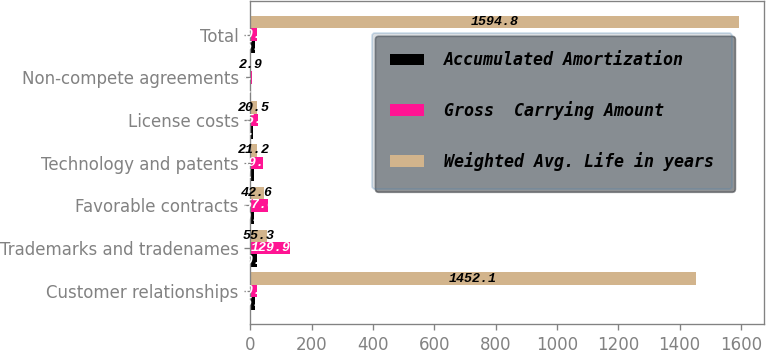Convert chart. <chart><loc_0><loc_0><loc_500><loc_500><stacked_bar_chart><ecel><fcel>Customer relationships<fcel>Trademarks and tradenames<fcel>Favorable contracts<fcel>Technology and patents<fcel>License costs<fcel>Non-compete agreements<fcel>Total<nl><fcel>Accumulated Amortization<fcel>15.3<fcel>20<fcel>10.1<fcel>11.4<fcel>9<fcel>2<fcel>15.3<nl><fcel>Gross  Carrying Amount<fcel>20.5<fcel>129.9<fcel>57<fcel>39.2<fcel>25.7<fcel>3.4<fcel>20.5<nl><fcel>Weighted Avg. Life in years<fcel>1452.1<fcel>55.3<fcel>42.6<fcel>21.2<fcel>20.5<fcel>2.9<fcel>1594.8<nl></chart> 